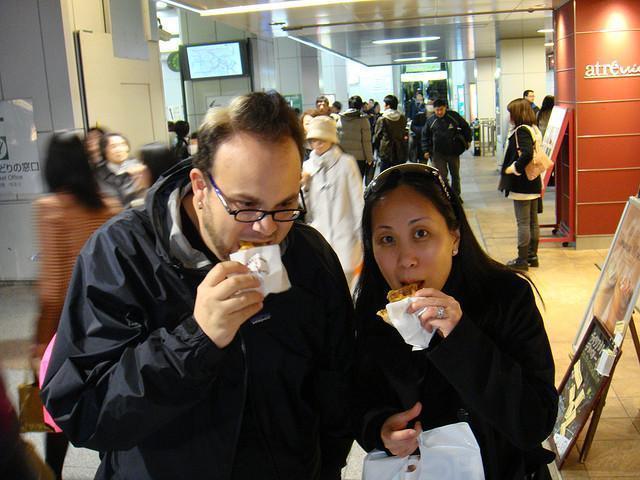How many tvs are in the photo?
Give a very brief answer. 1. How many people are in the photo?
Give a very brief answer. 7. How many horses are there?
Give a very brief answer. 0. 